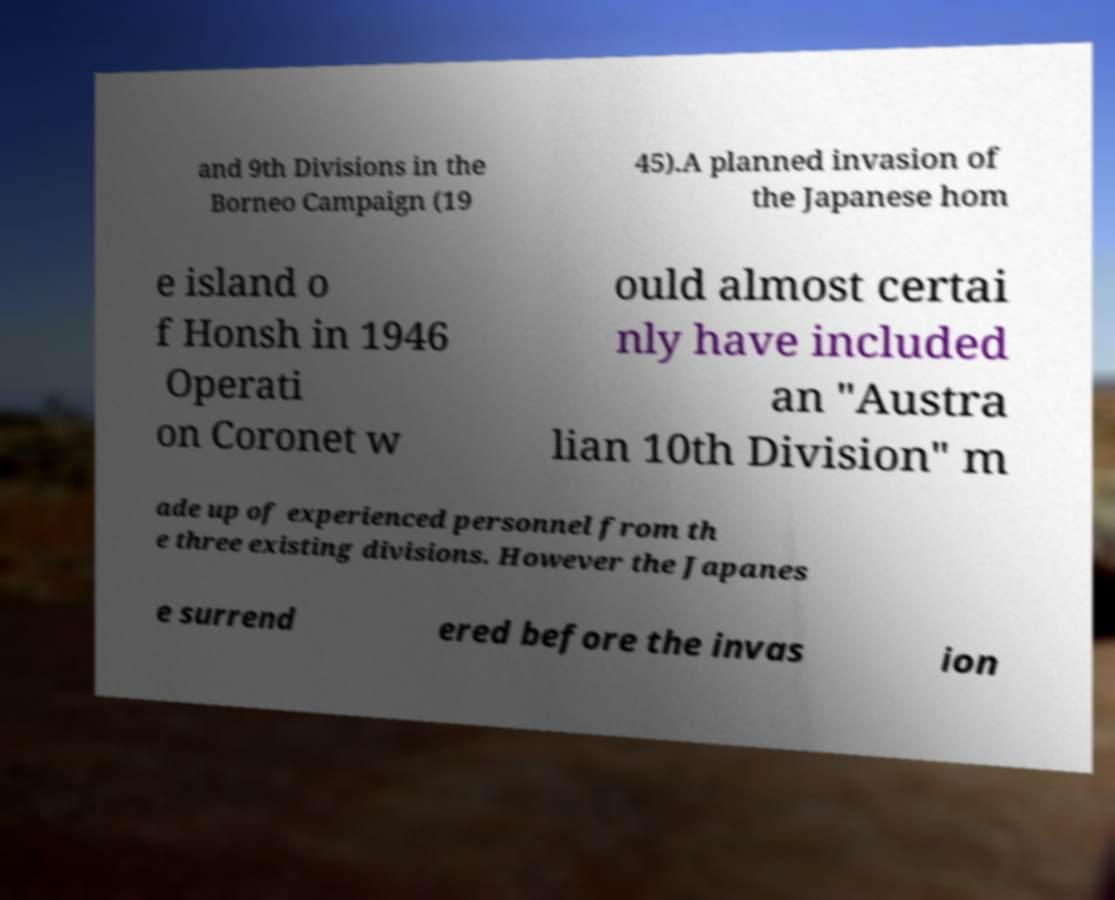Can you read and provide the text displayed in the image?This photo seems to have some interesting text. Can you extract and type it out for me? and 9th Divisions in the Borneo Campaign (19 45).A planned invasion of the Japanese hom e island o f Honsh in 1946 Operati on Coronet w ould almost certai nly have included an "Austra lian 10th Division" m ade up of experienced personnel from th e three existing divisions. However the Japanes e surrend ered before the invas ion 